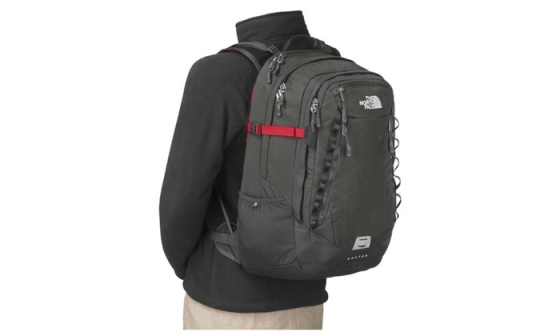Can you provide a detailed overview of the backpack's features? The backpack in the image is designed by North Face and is prominently equipped with a variety of features for functionality and convenience. It includes numerous external and internal zippered compartments that offer substantial storage space. The red chest strap is not only a visual focus but also adds to the ergonomic design, helping to distribute the weight evenly across the shoulders and chest. The padded shoulder straps are adjustable, ensuring a comfortable fit for the wearer. The backpack also includes side pockets, which are ideal for holding water bottles or other quick-access items. The material looks durable and weather-resistant, making it suitable for various outdoor activities. The white North Face logo on the front serves as a mark of brand authenticity and quality. How might this backpack be useful for a student? This North Face backpack would be incredibly useful for a student. Its ample storage capacity can accommodate books, notebooks, and other study materials, while the multiple compartments help keep items organized and easily accessible. The ergonomic design with adjustable straps ensures comfort, even when carrying a heavy load over long periods. Additionally, the side pockets are perfect for water bottles, ensuring the student stays hydrated throughout the day. The durable, weather-resistant material ensures the backpack can handle the daily wear and tear of a student’s routine. The stylish design, highlighted by the red strap and prominent logo, also makes it a fashionable choice for campus life. 